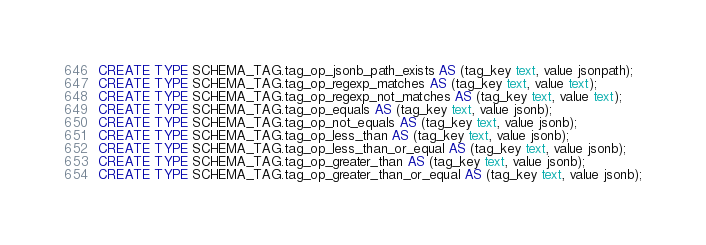<code> <loc_0><loc_0><loc_500><loc_500><_SQL_>CREATE TYPE SCHEMA_TAG.tag_op_jsonb_path_exists AS (tag_key text, value jsonpath);
CREATE TYPE SCHEMA_TAG.tag_op_regexp_matches AS (tag_key text, value text);
CREATE TYPE SCHEMA_TAG.tag_op_regexp_not_matches AS (tag_key text, value text);
CREATE TYPE SCHEMA_TAG.tag_op_equals AS (tag_key text, value jsonb);
CREATE TYPE SCHEMA_TAG.tag_op_not_equals AS (tag_key text, value jsonb);
CREATE TYPE SCHEMA_TAG.tag_op_less_than AS (tag_key text, value jsonb);
CREATE TYPE SCHEMA_TAG.tag_op_less_than_or_equal AS (tag_key text, value jsonb);
CREATE TYPE SCHEMA_TAG.tag_op_greater_than AS (tag_key text, value jsonb);
CREATE TYPE SCHEMA_TAG.tag_op_greater_than_or_equal AS (tag_key text, value jsonb);
</code> 